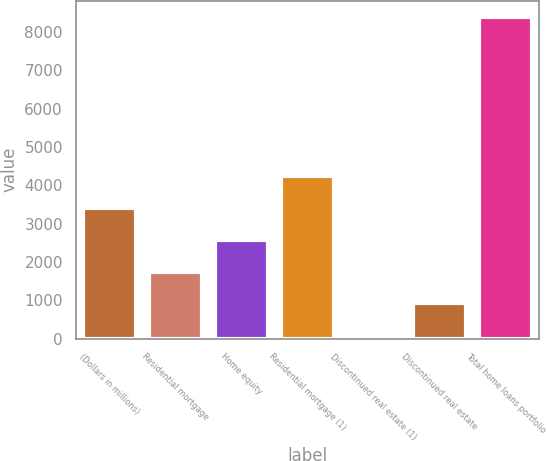Convert chart to OTSL. <chart><loc_0><loc_0><loc_500><loc_500><bar_chart><fcel>(Dollars in millions)<fcel>Residential mortgage<fcel>Home equity<fcel>Residential mortgage (1)<fcel>Discontinued real estate (1)<fcel>Discontinued real estate<fcel>Total home loans portfolio<nl><fcel>3414<fcel>1753<fcel>2583.5<fcel>4244.5<fcel>92<fcel>922.5<fcel>8397<nl></chart> 